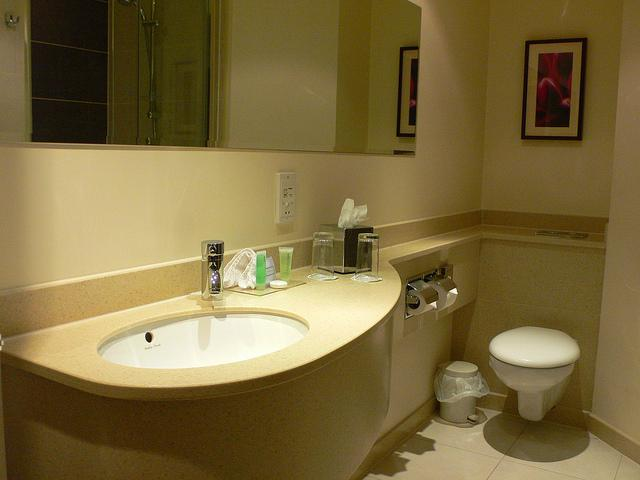What is missing from this picture?

Choices:
A) tissues
B) trash
C) brush
D) soap brush 